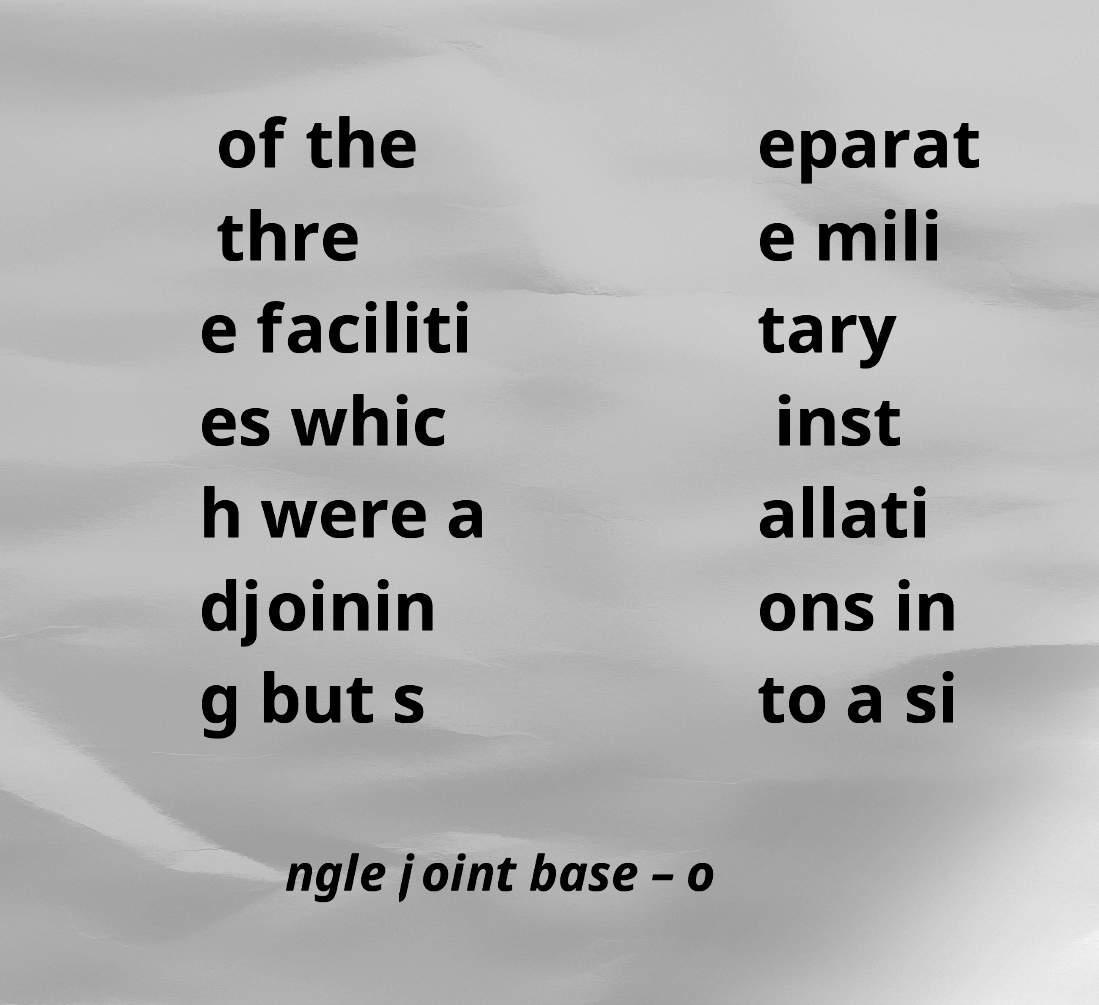I need the written content from this picture converted into text. Can you do that? of the thre e faciliti es whic h were a djoinin g but s eparat e mili tary inst allati ons in to a si ngle joint base – o 